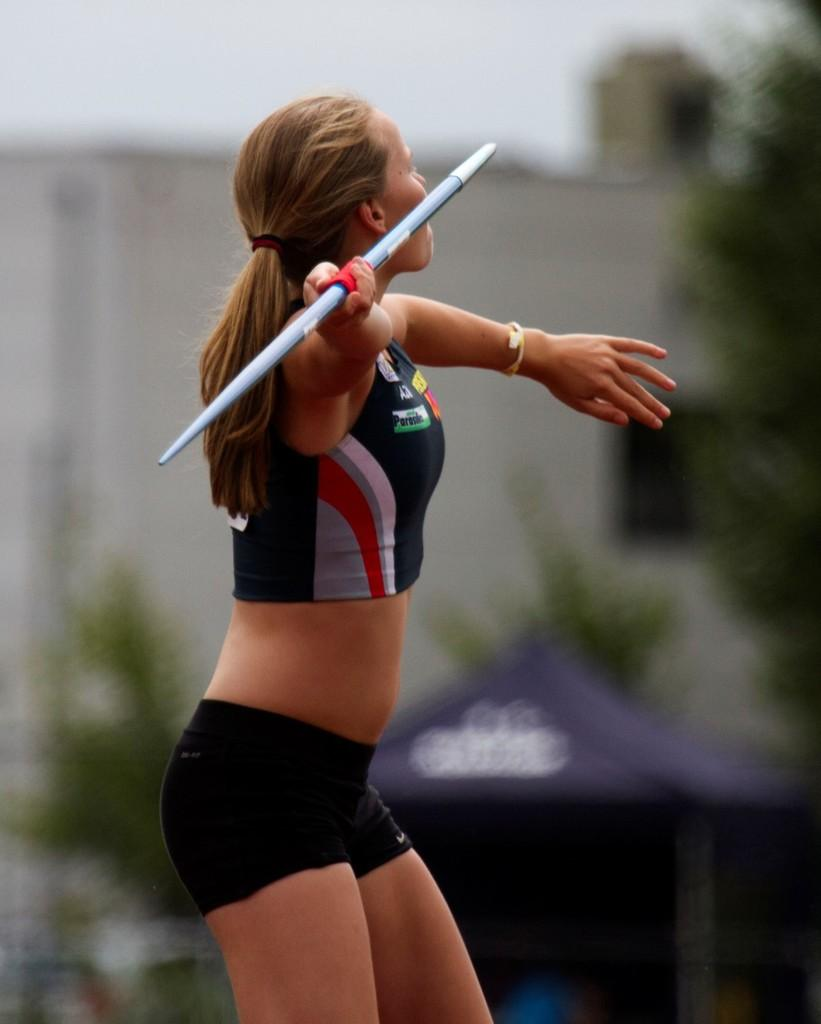Who is the main subject in the image? There is a girl in the image. What is the girl doing in the image? The girl is throwing a javelin. What can be seen in the background of the image? There is a tent and a building in the background of the image. What type of vegetation is on the right side of the image? There are trees on the right side of the image. What type of wire is being used by the girl to throw the javelin? There is no wire visible in the image; the girl is throwing a javelin without any visible wire. What type of yoke is the girl wearing while throwing the javelin? There is no yoke present in the image; the girl is not wearing any yoke while throwing the javelin. 